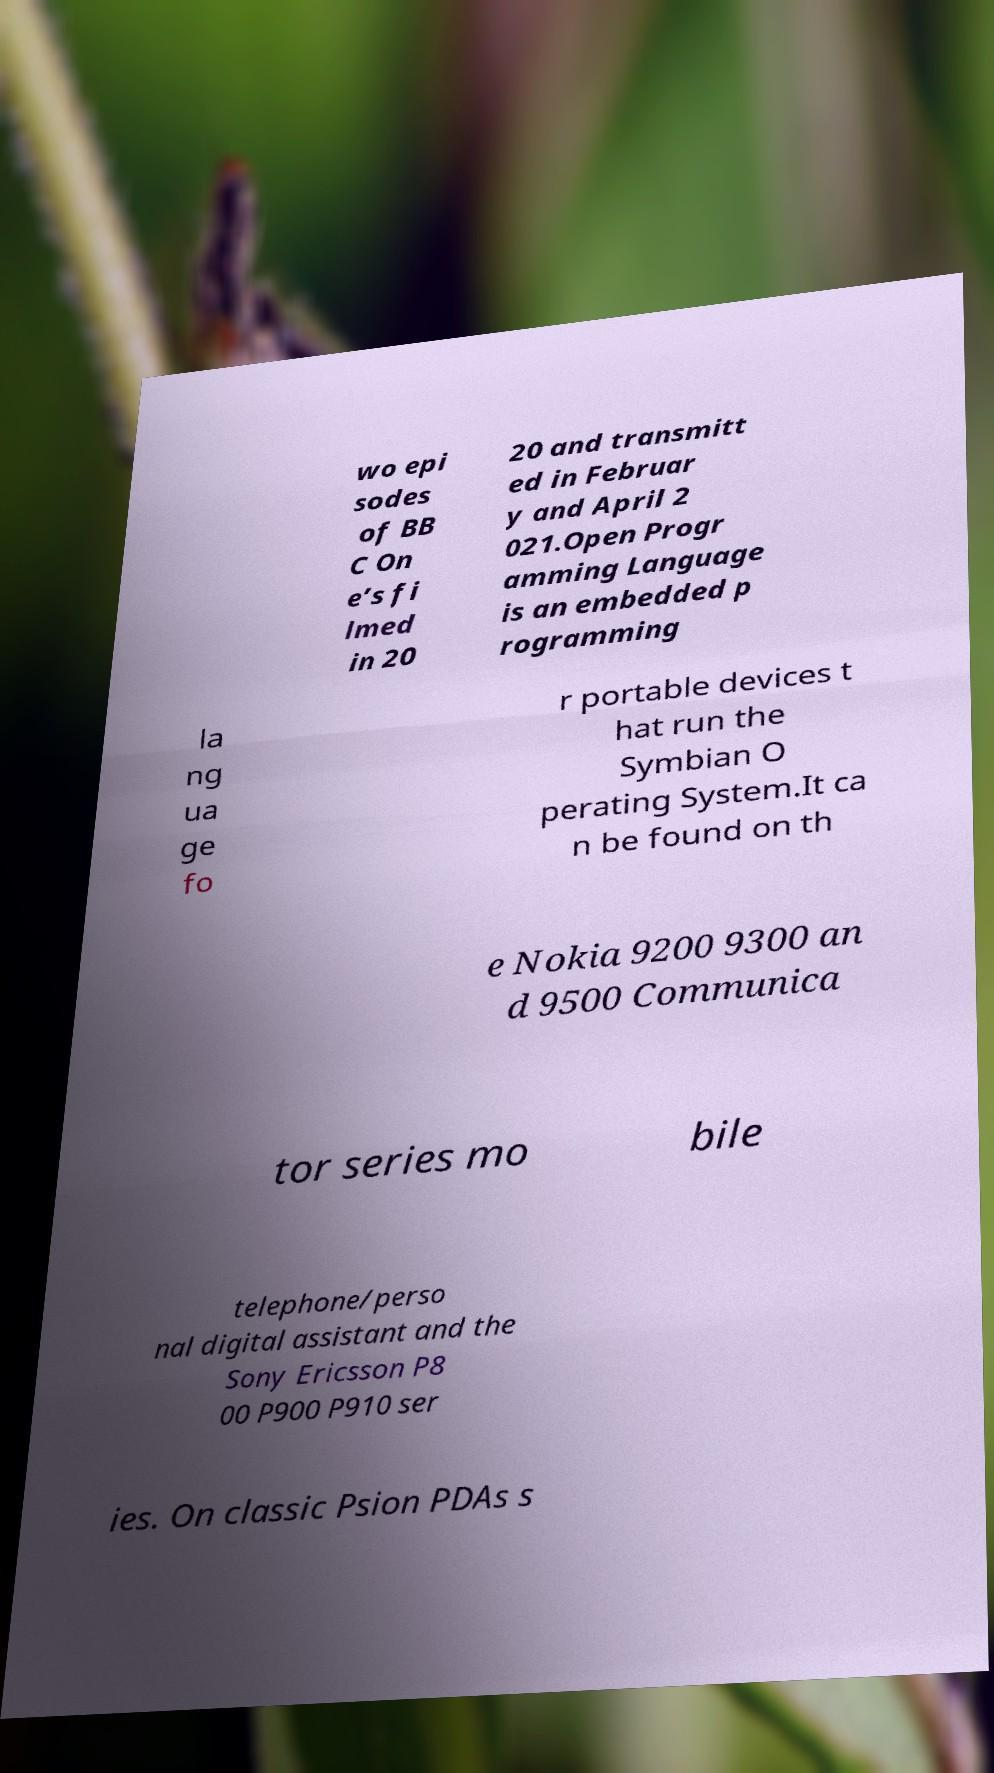What messages or text are displayed in this image? I need them in a readable, typed format. wo epi sodes of BB C On e’s fi lmed in 20 20 and transmitt ed in Februar y and April 2 021.Open Progr amming Language is an embedded p rogramming la ng ua ge fo r portable devices t hat run the Symbian O perating System.It ca n be found on th e Nokia 9200 9300 an d 9500 Communica tor series mo bile telephone/perso nal digital assistant and the Sony Ericsson P8 00 P900 P910 ser ies. On classic Psion PDAs s 